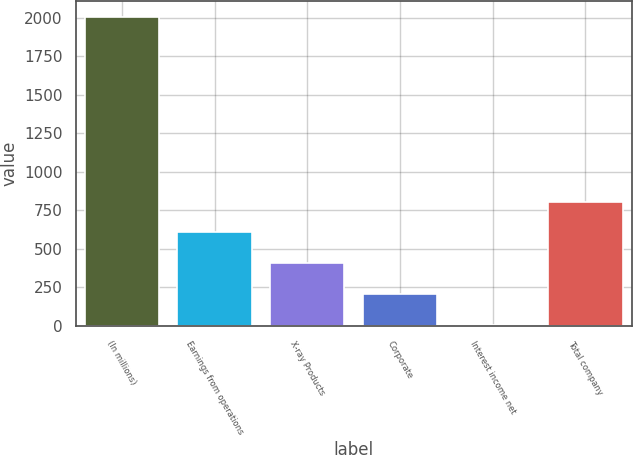<chart> <loc_0><loc_0><loc_500><loc_500><bar_chart><fcel>(In millions)<fcel>Earnings from operations<fcel>X-ray Products<fcel>Corporate<fcel>Interest income net<fcel>Total company<nl><fcel>2007<fcel>607<fcel>407<fcel>207<fcel>7<fcel>807<nl></chart> 